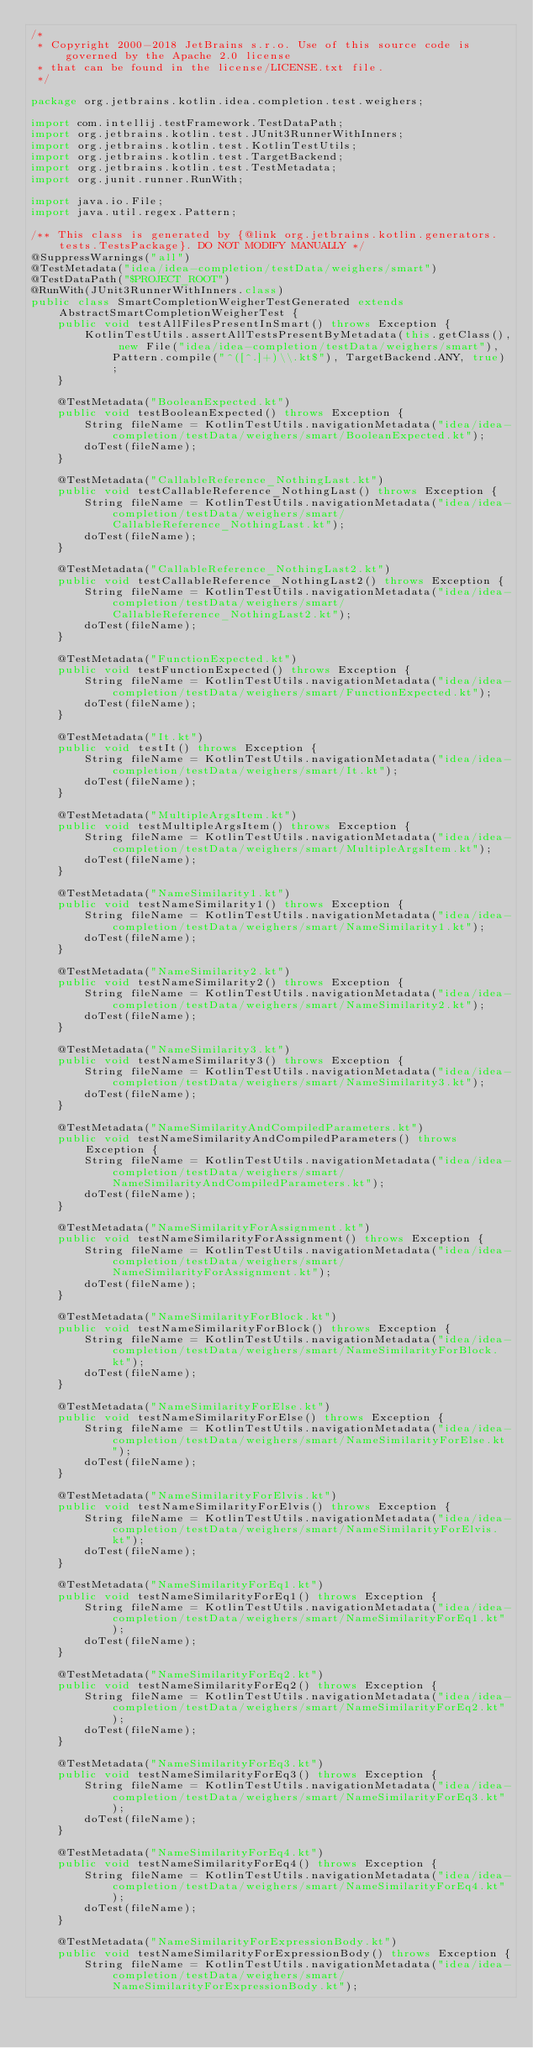Convert code to text. <code><loc_0><loc_0><loc_500><loc_500><_Java_>/*
 * Copyright 2000-2018 JetBrains s.r.o. Use of this source code is governed by the Apache 2.0 license
 * that can be found in the license/LICENSE.txt file.
 */

package org.jetbrains.kotlin.idea.completion.test.weighers;

import com.intellij.testFramework.TestDataPath;
import org.jetbrains.kotlin.test.JUnit3RunnerWithInners;
import org.jetbrains.kotlin.test.KotlinTestUtils;
import org.jetbrains.kotlin.test.TargetBackend;
import org.jetbrains.kotlin.test.TestMetadata;
import org.junit.runner.RunWith;

import java.io.File;
import java.util.regex.Pattern;

/** This class is generated by {@link org.jetbrains.kotlin.generators.tests.TestsPackage}. DO NOT MODIFY MANUALLY */
@SuppressWarnings("all")
@TestMetadata("idea/idea-completion/testData/weighers/smart")
@TestDataPath("$PROJECT_ROOT")
@RunWith(JUnit3RunnerWithInners.class)
public class SmartCompletionWeigherTestGenerated extends AbstractSmartCompletionWeigherTest {
    public void testAllFilesPresentInSmart() throws Exception {
        KotlinTestUtils.assertAllTestsPresentByMetadata(this.getClass(), new File("idea/idea-completion/testData/weighers/smart"), Pattern.compile("^([^.]+)\\.kt$"), TargetBackend.ANY, true);
    }

    @TestMetadata("BooleanExpected.kt")
    public void testBooleanExpected() throws Exception {
        String fileName = KotlinTestUtils.navigationMetadata("idea/idea-completion/testData/weighers/smart/BooleanExpected.kt");
        doTest(fileName);
    }

    @TestMetadata("CallableReference_NothingLast.kt")
    public void testCallableReference_NothingLast() throws Exception {
        String fileName = KotlinTestUtils.navigationMetadata("idea/idea-completion/testData/weighers/smart/CallableReference_NothingLast.kt");
        doTest(fileName);
    }

    @TestMetadata("CallableReference_NothingLast2.kt")
    public void testCallableReference_NothingLast2() throws Exception {
        String fileName = KotlinTestUtils.navigationMetadata("idea/idea-completion/testData/weighers/smart/CallableReference_NothingLast2.kt");
        doTest(fileName);
    }

    @TestMetadata("FunctionExpected.kt")
    public void testFunctionExpected() throws Exception {
        String fileName = KotlinTestUtils.navigationMetadata("idea/idea-completion/testData/weighers/smart/FunctionExpected.kt");
        doTest(fileName);
    }

    @TestMetadata("It.kt")
    public void testIt() throws Exception {
        String fileName = KotlinTestUtils.navigationMetadata("idea/idea-completion/testData/weighers/smart/It.kt");
        doTest(fileName);
    }

    @TestMetadata("MultipleArgsItem.kt")
    public void testMultipleArgsItem() throws Exception {
        String fileName = KotlinTestUtils.navigationMetadata("idea/idea-completion/testData/weighers/smart/MultipleArgsItem.kt");
        doTest(fileName);
    }

    @TestMetadata("NameSimilarity1.kt")
    public void testNameSimilarity1() throws Exception {
        String fileName = KotlinTestUtils.navigationMetadata("idea/idea-completion/testData/weighers/smart/NameSimilarity1.kt");
        doTest(fileName);
    }

    @TestMetadata("NameSimilarity2.kt")
    public void testNameSimilarity2() throws Exception {
        String fileName = KotlinTestUtils.navigationMetadata("idea/idea-completion/testData/weighers/smart/NameSimilarity2.kt");
        doTest(fileName);
    }

    @TestMetadata("NameSimilarity3.kt")
    public void testNameSimilarity3() throws Exception {
        String fileName = KotlinTestUtils.navigationMetadata("idea/idea-completion/testData/weighers/smart/NameSimilarity3.kt");
        doTest(fileName);
    }

    @TestMetadata("NameSimilarityAndCompiledParameters.kt")
    public void testNameSimilarityAndCompiledParameters() throws Exception {
        String fileName = KotlinTestUtils.navigationMetadata("idea/idea-completion/testData/weighers/smart/NameSimilarityAndCompiledParameters.kt");
        doTest(fileName);
    }

    @TestMetadata("NameSimilarityForAssignment.kt")
    public void testNameSimilarityForAssignment() throws Exception {
        String fileName = KotlinTestUtils.navigationMetadata("idea/idea-completion/testData/weighers/smart/NameSimilarityForAssignment.kt");
        doTest(fileName);
    }

    @TestMetadata("NameSimilarityForBlock.kt")
    public void testNameSimilarityForBlock() throws Exception {
        String fileName = KotlinTestUtils.navigationMetadata("idea/idea-completion/testData/weighers/smart/NameSimilarityForBlock.kt");
        doTest(fileName);
    }

    @TestMetadata("NameSimilarityForElse.kt")
    public void testNameSimilarityForElse() throws Exception {
        String fileName = KotlinTestUtils.navigationMetadata("idea/idea-completion/testData/weighers/smart/NameSimilarityForElse.kt");
        doTest(fileName);
    }

    @TestMetadata("NameSimilarityForElvis.kt")
    public void testNameSimilarityForElvis() throws Exception {
        String fileName = KotlinTestUtils.navigationMetadata("idea/idea-completion/testData/weighers/smart/NameSimilarityForElvis.kt");
        doTest(fileName);
    }

    @TestMetadata("NameSimilarityForEq1.kt")
    public void testNameSimilarityForEq1() throws Exception {
        String fileName = KotlinTestUtils.navigationMetadata("idea/idea-completion/testData/weighers/smart/NameSimilarityForEq1.kt");
        doTest(fileName);
    }

    @TestMetadata("NameSimilarityForEq2.kt")
    public void testNameSimilarityForEq2() throws Exception {
        String fileName = KotlinTestUtils.navigationMetadata("idea/idea-completion/testData/weighers/smart/NameSimilarityForEq2.kt");
        doTest(fileName);
    }

    @TestMetadata("NameSimilarityForEq3.kt")
    public void testNameSimilarityForEq3() throws Exception {
        String fileName = KotlinTestUtils.navigationMetadata("idea/idea-completion/testData/weighers/smart/NameSimilarityForEq3.kt");
        doTest(fileName);
    }

    @TestMetadata("NameSimilarityForEq4.kt")
    public void testNameSimilarityForEq4() throws Exception {
        String fileName = KotlinTestUtils.navigationMetadata("idea/idea-completion/testData/weighers/smart/NameSimilarityForEq4.kt");
        doTest(fileName);
    }

    @TestMetadata("NameSimilarityForExpressionBody.kt")
    public void testNameSimilarityForExpressionBody() throws Exception {
        String fileName = KotlinTestUtils.navigationMetadata("idea/idea-completion/testData/weighers/smart/NameSimilarityForExpressionBody.kt");</code> 